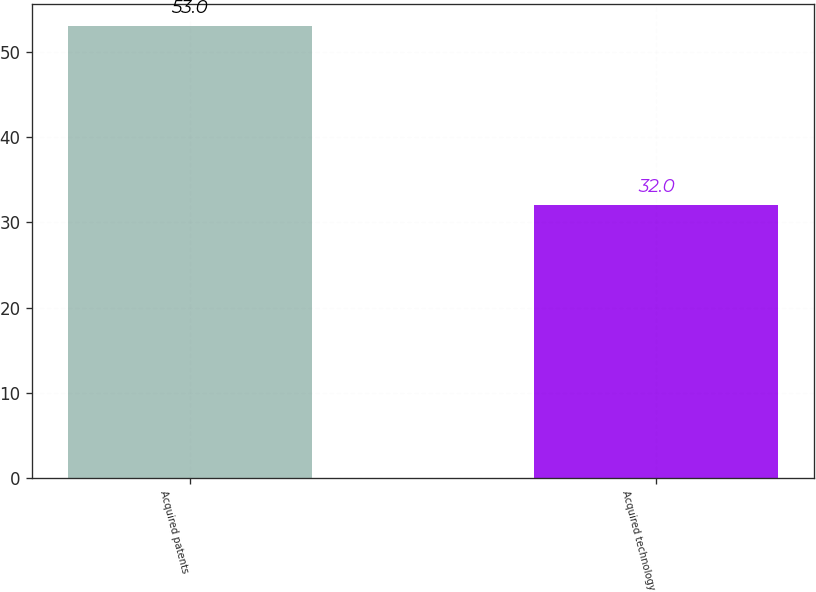<chart> <loc_0><loc_0><loc_500><loc_500><bar_chart><fcel>Acquired patents<fcel>Acquired technology<nl><fcel>53<fcel>32<nl></chart> 